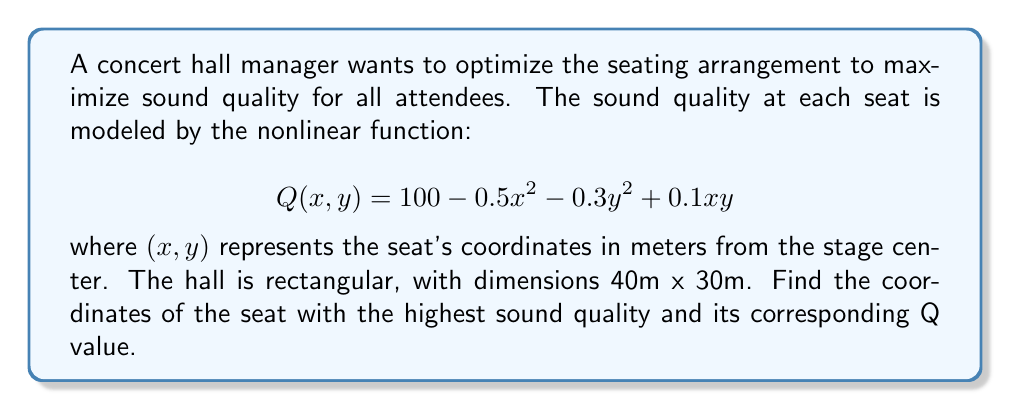Can you solve this math problem? To find the optimal seating position, we need to maximize the function $Q(x, y)$. This is a nonlinear optimization problem.

Step 1: Find the critical points by taking partial derivatives and setting them to zero.

$$\frac{\partial Q}{\partial x} = -x + 0.1y = 0$$
$$\frac{\partial Q}{\partial y} = -0.6y + 0.1x = 0$$

Step 2: Solve the system of equations.
From the first equation: $x = 0.1y$
Substituting into the second equation:
$$-0.6y + 0.1(0.1y) = 0$$
$$-0.6y + 0.01y = 0$$
$$-0.59y = 0$$
$$y = 0$$

If $y = 0$, then $x = 0.1(0) = 0$

Step 3: Verify that this critical point $(0, 0)$ is a maximum by checking the second partial derivatives.

$$\frac{\partial^2 Q}{\partial x^2} = -1$$
$$\frac{\partial^2 Q}{\partial y^2} = -0.6$$
$$\frac{\partial^2 Q}{\partial x\partial y} = 0.1$$

The Hessian matrix at $(0, 0)$ is:
$$H = \begin{bmatrix} -1 & 0.1 \\ 0.1 & -0.6 \end{bmatrix}$$

Since the determinant is positive $(0.6 - 0.01 = 0.59 > 0)$ and $\frac{\partial^2 Q}{\partial x^2} < 0$, this point is a local maximum.

Step 4: Calculate the Q value at $(0, 0)$.
$$Q(0, 0) = 100 - 0.5(0)^2 - 0.3(0)^2 + 0.1(0)(0) = 100$$

Therefore, the optimal seating position is at the center of the stage $(0, 0)$, with a maximum sound quality value of 100.
Answer: $(0, 0)$, $Q = 100$ 